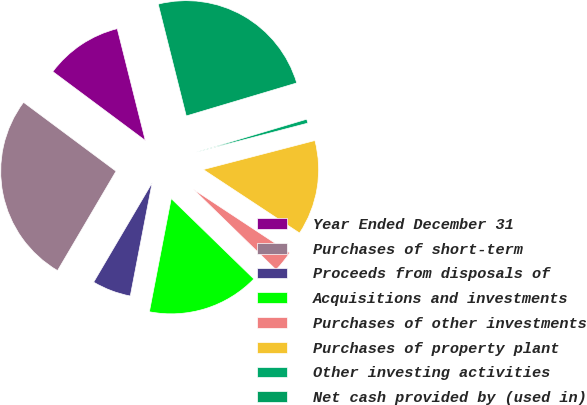Convert chart. <chart><loc_0><loc_0><loc_500><loc_500><pie_chart><fcel>Year Ended December 31<fcel>Purchases of short-term<fcel>Proceeds from disposals of<fcel>Acquisitions and investments<fcel>Purchases of other investments<fcel>Purchases of property plant<fcel>Other investing activities<fcel>Net cash provided by (used in)<nl><fcel>10.9%<fcel>26.72%<fcel>5.43%<fcel>15.75%<fcel>3.0%<fcel>13.33%<fcel>0.57%<fcel>24.29%<nl></chart> 